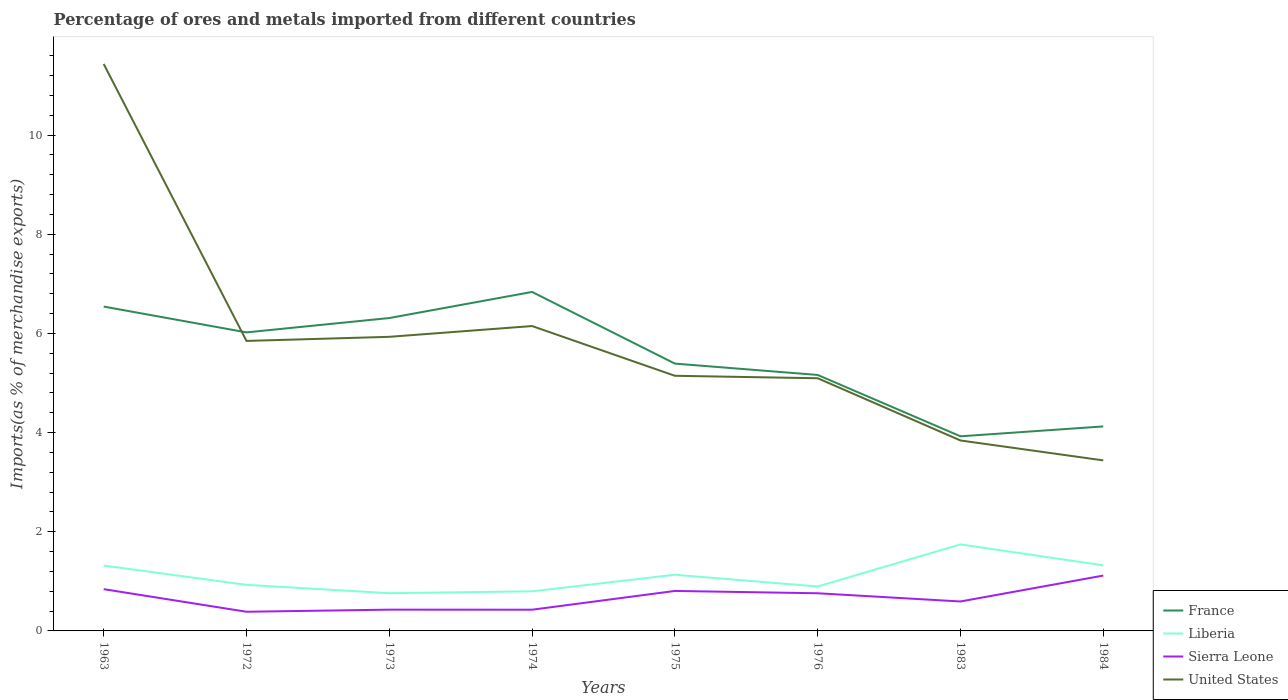Across all years, what is the maximum percentage of imports to different countries in Sierra Leone?
Keep it short and to the point. 0.39. What is the total percentage of imports to different countries in France in the graph?
Keep it short and to the point. 2.1. What is the difference between the highest and the second highest percentage of imports to different countries in France?
Your answer should be very brief. 2.91. What is the difference between two consecutive major ticks on the Y-axis?
Provide a succinct answer. 2. Does the graph contain grids?
Keep it short and to the point. No. How many legend labels are there?
Your response must be concise. 4. How are the legend labels stacked?
Make the answer very short. Vertical. What is the title of the graph?
Offer a very short reply. Percentage of ores and metals imported from different countries. Does "French Polynesia" appear as one of the legend labels in the graph?
Your answer should be very brief. No. What is the label or title of the X-axis?
Keep it short and to the point. Years. What is the label or title of the Y-axis?
Your answer should be compact. Imports(as % of merchandise exports). What is the Imports(as % of merchandise exports) in France in 1963?
Ensure brevity in your answer.  6.54. What is the Imports(as % of merchandise exports) in Liberia in 1963?
Ensure brevity in your answer.  1.32. What is the Imports(as % of merchandise exports) of Sierra Leone in 1963?
Your answer should be compact. 0.84. What is the Imports(as % of merchandise exports) in United States in 1963?
Your answer should be compact. 11.43. What is the Imports(as % of merchandise exports) of France in 1972?
Give a very brief answer. 6.02. What is the Imports(as % of merchandise exports) in Liberia in 1972?
Ensure brevity in your answer.  0.93. What is the Imports(as % of merchandise exports) in Sierra Leone in 1972?
Ensure brevity in your answer.  0.39. What is the Imports(as % of merchandise exports) in United States in 1972?
Keep it short and to the point. 5.85. What is the Imports(as % of merchandise exports) of France in 1973?
Your answer should be compact. 6.31. What is the Imports(as % of merchandise exports) in Liberia in 1973?
Your answer should be compact. 0.76. What is the Imports(as % of merchandise exports) of Sierra Leone in 1973?
Offer a terse response. 0.43. What is the Imports(as % of merchandise exports) in United States in 1973?
Offer a very short reply. 5.93. What is the Imports(as % of merchandise exports) of France in 1974?
Keep it short and to the point. 6.84. What is the Imports(as % of merchandise exports) of Liberia in 1974?
Ensure brevity in your answer.  0.8. What is the Imports(as % of merchandise exports) of Sierra Leone in 1974?
Give a very brief answer. 0.43. What is the Imports(as % of merchandise exports) in United States in 1974?
Offer a terse response. 6.15. What is the Imports(as % of merchandise exports) of France in 1975?
Provide a short and direct response. 5.39. What is the Imports(as % of merchandise exports) of Liberia in 1975?
Provide a succinct answer. 1.13. What is the Imports(as % of merchandise exports) in Sierra Leone in 1975?
Make the answer very short. 0.81. What is the Imports(as % of merchandise exports) of United States in 1975?
Provide a succinct answer. 5.15. What is the Imports(as % of merchandise exports) of France in 1976?
Offer a very short reply. 5.16. What is the Imports(as % of merchandise exports) in Liberia in 1976?
Your response must be concise. 0.9. What is the Imports(as % of merchandise exports) of Sierra Leone in 1976?
Keep it short and to the point. 0.76. What is the Imports(as % of merchandise exports) in United States in 1976?
Offer a terse response. 5.1. What is the Imports(as % of merchandise exports) in France in 1983?
Your response must be concise. 3.93. What is the Imports(as % of merchandise exports) in Liberia in 1983?
Offer a terse response. 1.74. What is the Imports(as % of merchandise exports) in Sierra Leone in 1983?
Offer a terse response. 0.59. What is the Imports(as % of merchandise exports) in United States in 1983?
Offer a terse response. 3.84. What is the Imports(as % of merchandise exports) in France in 1984?
Provide a succinct answer. 4.12. What is the Imports(as % of merchandise exports) in Liberia in 1984?
Ensure brevity in your answer.  1.32. What is the Imports(as % of merchandise exports) of Sierra Leone in 1984?
Your response must be concise. 1.12. What is the Imports(as % of merchandise exports) in United States in 1984?
Provide a succinct answer. 3.44. Across all years, what is the maximum Imports(as % of merchandise exports) of France?
Keep it short and to the point. 6.84. Across all years, what is the maximum Imports(as % of merchandise exports) of Liberia?
Your answer should be compact. 1.74. Across all years, what is the maximum Imports(as % of merchandise exports) of Sierra Leone?
Provide a short and direct response. 1.12. Across all years, what is the maximum Imports(as % of merchandise exports) in United States?
Your response must be concise. 11.43. Across all years, what is the minimum Imports(as % of merchandise exports) of France?
Offer a terse response. 3.93. Across all years, what is the minimum Imports(as % of merchandise exports) of Liberia?
Your response must be concise. 0.76. Across all years, what is the minimum Imports(as % of merchandise exports) of Sierra Leone?
Your answer should be very brief. 0.39. Across all years, what is the minimum Imports(as % of merchandise exports) in United States?
Keep it short and to the point. 3.44. What is the total Imports(as % of merchandise exports) in France in the graph?
Provide a succinct answer. 44.31. What is the total Imports(as % of merchandise exports) of Liberia in the graph?
Your answer should be compact. 8.9. What is the total Imports(as % of merchandise exports) of Sierra Leone in the graph?
Offer a very short reply. 5.36. What is the total Imports(as % of merchandise exports) in United States in the graph?
Give a very brief answer. 46.89. What is the difference between the Imports(as % of merchandise exports) of France in 1963 and that in 1972?
Provide a short and direct response. 0.52. What is the difference between the Imports(as % of merchandise exports) in Liberia in 1963 and that in 1972?
Provide a short and direct response. 0.39. What is the difference between the Imports(as % of merchandise exports) of Sierra Leone in 1963 and that in 1972?
Keep it short and to the point. 0.46. What is the difference between the Imports(as % of merchandise exports) of United States in 1963 and that in 1972?
Your response must be concise. 5.59. What is the difference between the Imports(as % of merchandise exports) of France in 1963 and that in 1973?
Keep it short and to the point. 0.23. What is the difference between the Imports(as % of merchandise exports) of Liberia in 1963 and that in 1973?
Make the answer very short. 0.56. What is the difference between the Imports(as % of merchandise exports) in Sierra Leone in 1963 and that in 1973?
Give a very brief answer. 0.41. What is the difference between the Imports(as % of merchandise exports) in United States in 1963 and that in 1973?
Offer a terse response. 5.5. What is the difference between the Imports(as % of merchandise exports) of France in 1963 and that in 1974?
Give a very brief answer. -0.29. What is the difference between the Imports(as % of merchandise exports) in Liberia in 1963 and that in 1974?
Your answer should be very brief. 0.52. What is the difference between the Imports(as % of merchandise exports) of Sierra Leone in 1963 and that in 1974?
Provide a succinct answer. 0.41. What is the difference between the Imports(as % of merchandise exports) of United States in 1963 and that in 1974?
Your answer should be compact. 5.29. What is the difference between the Imports(as % of merchandise exports) of France in 1963 and that in 1975?
Offer a very short reply. 1.15. What is the difference between the Imports(as % of merchandise exports) in Liberia in 1963 and that in 1975?
Make the answer very short. 0.18. What is the difference between the Imports(as % of merchandise exports) of Sierra Leone in 1963 and that in 1975?
Offer a terse response. 0.04. What is the difference between the Imports(as % of merchandise exports) of United States in 1963 and that in 1975?
Your answer should be compact. 6.29. What is the difference between the Imports(as % of merchandise exports) in France in 1963 and that in 1976?
Ensure brevity in your answer.  1.38. What is the difference between the Imports(as % of merchandise exports) in Liberia in 1963 and that in 1976?
Provide a short and direct response. 0.42. What is the difference between the Imports(as % of merchandise exports) in Sierra Leone in 1963 and that in 1976?
Provide a succinct answer. 0.08. What is the difference between the Imports(as % of merchandise exports) in United States in 1963 and that in 1976?
Make the answer very short. 6.34. What is the difference between the Imports(as % of merchandise exports) in France in 1963 and that in 1983?
Your answer should be compact. 2.62. What is the difference between the Imports(as % of merchandise exports) of Liberia in 1963 and that in 1983?
Ensure brevity in your answer.  -0.43. What is the difference between the Imports(as % of merchandise exports) of Sierra Leone in 1963 and that in 1983?
Your response must be concise. 0.25. What is the difference between the Imports(as % of merchandise exports) in United States in 1963 and that in 1983?
Give a very brief answer. 7.59. What is the difference between the Imports(as % of merchandise exports) of France in 1963 and that in 1984?
Provide a succinct answer. 2.42. What is the difference between the Imports(as % of merchandise exports) of Liberia in 1963 and that in 1984?
Make the answer very short. -0. What is the difference between the Imports(as % of merchandise exports) in Sierra Leone in 1963 and that in 1984?
Make the answer very short. -0.27. What is the difference between the Imports(as % of merchandise exports) of United States in 1963 and that in 1984?
Provide a succinct answer. 8. What is the difference between the Imports(as % of merchandise exports) of France in 1972 and that in 1973?
Your answer should be very brief. -0.29. What is the difference between the Imports(as % of merchandise exports) of Liberia in 1972 and that in 1973?
Your answer should be very brief. 0.17. What is the difference between the Imports(as % of merchandise exports) in Sierra Leone in 1972 and that in 1973?
Offer a very short reply. -0.04. What is the difference between the Imports(as % of merchandise exports) in United States in 1972 and that in 1973?
Provide a short and direct response. -0.08. What is the difference between the Imports(as % of merchandise exports) in France in 1972 and that in 1974?
Your response must be concise. -0.82. What is the difference between the Imports(as % of merchandise exports) of Liberia in 1972 and that in 1974?
Your response must be concise. 0.13. What is the difference between the Imports(as % of merchandise exports) of Sierra Leone in 1972 and that in 1974?
Offer a very short reply. -0.04. What is the difference between the Imports(as % of merchandise exports) of United States in 1972 and that in 1974?
Offer a terse response. -0.3. What is the difference between the Imports(as % of merchandise exports) of France in 1972 and that in 1975?
Offer a terse response. 0.63. What is the difference between the Imports(as % of merchandise exports) of Liberia in 1972 and that in 1975?
Make the answer very short. -0.2. What is the difference between the Imports(as % of merchandise exports) in Sierra Leone in 1972 and that in 1975?
Give a very brief answer. -0.42. What is the difference between the Imports(as % of merchandise exports) in United States in 1972 and that in 1975?
Make the answer very short. 0.7. What is the difference between the Imports(as % of merchandise exports) of France in 1972 and that in 1976?
Ensure brevity in your answer.  0.86. What is the difference between the Imports(as % of merchandise exports) of Liberia in 1972 and that in 1976?
Your answer should be compact. 0.03. What is the difference between the Imports(as % of merchandise exports) in Sierra Leone in 1972 and that in 1976?
Offer a terse response. -0.37. What is the difference between the Imports(as % of merchandise exports) of United States in 1972 and that in 1976?
Provide a succinct answer. 0.75. What is the difference between the Imports(as % of merchandise exports) in France in 1972 and that in 1983?
Your answer should be compact. 2.1. What is the difference between the Imports(as % of merchandise exports) in Liberia in 1972 and that in 1983?
Offer a very short reply. -0.82. What is the difference between the Imports(as % of merchandise exports) of Sierra Leone in 1972 and that in 1983?
Your answer should be very brief. -0.21. What is the difference between the Imports(as % of merchandise exports) of United States in 1972 and that in 1983?
Offer a very short reply. 2.01. What is the difference between the Imports(as % of merchandise exports) in France in 1972 and that in 1984?
Keep it short and to the point. 1.9. What is the difference between the Imports(as % of merchandise exports) in Liberia in 1972 and that in 1984?
Provide a succinct answer. -0.39. What is the difference between the Imports(as % of merchandise exports) in Sierra Leone in 1972 and that in 1984?
Provide a short and direct response. -0.73. What is the difference between the Imports(as % of merchandise exports) in United States in 1972 and that in 1984?
Ensure brevity in your answer.  2.41. What is the difference between the Imports(as % of merchandise exports) in France in 1973 and that in 1974?
Offer a very short reply. -0.53. What is the difference between the Imports(as % of merchandise exports) of Liberia in 1973 and that in 1974?
Offer a terse response. -0.04. What is the difference between the Imports(as % of merchandise exports) in Sierra Leone in 1973 and that in 1974?
Provide a succinct answer. 0. What is the difference between the Imports(as % of merchandise exports) of United States in 1973 and that in 1974?
Offer a very short reply. -0.22. What is the difference between the Imports(as % of merchandise exports) in France in 1973 and that in 1975?
Make the answer very short. 0.92. What is the difference between the Imports(as % of merchandise exports) of Liberia in 1973 and that in 1975?
Offer a terse response. -0.37. What is the difference between the Imports(as % of merchandise exports) of Sierra Leone in 1973 and that in 1975?
Your answer should be very brief. -0.38. What is the difference between the Imports(as % of merchandise exports) in United States in 1973 and that in 1975?
Ensure brevity in your answer.  0.79. What is the difference between the Imports(as % of merchandise exports) of France in 1973 and that in 1976?
Ensure brevity in your answer.  1.15. What is the difference between the Imports(as % of merchandise exports) of Liberia in 1973 and that in 1976?
Your answer should be very brief. -0.14. What is the difference between the Imports(as % of merchandise exports) in Sierra Leone in 1973 and that in 1976?
Make the answer very short. -0.33. What is the difference between the Imports(as % of merchandise exports) in United States in 1973 and that in 1976?
Offer a very short reply. 0.84. What is the difference between the Imports(as % of merchandise exports) of France in 1973 and that in 1983?
Keep it short and to the point. 2.39. What is the difference between the Imports(as % of merchandise exports) in Liberia in 1973 and that in 1983?
Keep it short and to the point. -0.98. What is the difference between the Imports(as % of merchandise exports) in Sierra Leone in 1973 and that in 1983?
Provide a succinct answer. -0.16. What is the difference between the Imports(as % of merchandise exports) in United States in 1973 and that in 1983?
Give a very brief answer. 2.09. What is the difference between the Imports(as % of merchandise exports) of France in 1973 and that in 1984?
Your answer should be compact. 2.19. What is the difference between the Imports(as % of merchandise exports) in Liberia in 1973 and that in 1984?
Keep it short and to the point. -0.56. What is the difference between the Imports(as % of merchandise exports) of Sierra Leone in 1973 and that in 1984?
Your answer should be compact. -0.69. What is the difference between the Imports(as % of merchandise exports) of United States in 1973 and that in 1984?
Make the answer very short. 2.49. What is the difference between the Imports(as % of merchandise exports) of France in 1974 and that in 1975?
Your response must be concise. 1.45. What is the difference between the Imports(as % of merchandise exports) of Liberia in 1974 and that in 1975?
Offer a very short reply. -0.33. What is the difference between the Imports(as % of merchandise exports) in Sierra Leone in 1974 and that in 1975?
Provide a succinct answer. -0.38. What is the difference between the Imports(as % of merchandise exports) of United States in 1974 and that in 1975?
Keep it short and to the point. 1. What is the difference between the Imports(as % of merchandise exports) in France in 1974 and that in 1976?
Your response must be concise. 1.67. What is the difference between the Imports(as % of merchandise exports) of Liberia in 1974 and that in 1976?
Your response must be concise. -0.1. What is the difference between the Imports(as % of merchandise exports) of Sierra Leone in 1974 and that in 1976?
Give a very brief answer. -0.33. What is the difference between the Imports(as % of merchandise exports) of United States in 1974 and that in 1976?
Provide a short and direct response. 1.05. What is the difference between the Imports(as % of merchandise exports) in France in 1974 and that in 1983?
Ensure brevity in your answer.  2.91. What is the difference between the Imports(as % of merchandise exports) of Liberia in 1974 and that in 1983?
Offer a terse response. -0.95. What is the difference between the Imports(as % of merchandise exports) of Sierra Leone in 1974 and that in 1983?
Offer a very short reply. -0.17. What is the difference between the Imports(as % of merchandise exports) of United States in 1974 and that in 1983?
Your response must be concise. 2.31. What is the difference between the Imports(as % of merchandise exports) of France in 1974 and that in 1984?
Make the answer very short. 2.71. What is the difference between the Imports(as % of merchandise exports) in Liberia in 1974 and that in 1984?
Offer a terse response. -0.52. What is the difference between the Imports(as % of merchandise exports) in Sierra Leone in 1974 and that in 1984?
Your response must be concise. -0.69. What is the difference between the Imports(as % of merchandise exports) in United States in 1974 and that in 1984?
Your answer should be very brief. 2.71. What is the difference between the Imports(as % of merchandise exports) of France in 1975 and that in 1976?
Ensure brevity in your answer.  0.23. What is the difference between the Imports(as % of merchandise exports) in Liberia in 1975 and that in 1976?
Your response must be concise. 0.24. What is the difference between the Imports(as % of merchandise exports) of Sierra Leone in 1975 and that in 1976?
Offer a very short reply. 0.05. What is the difference between the Imports(as % of merchandise exports) in United States in 1975 and that in 1976?
Your answer should be compact. 0.05. What is the difference between the Imports(as % of merchandise exports) of France in 1975 and that in 1983?
Make the answer very short. 1.47. What is the difference between the Imports(as % of merchandise exports) of Liberia in 1975 and that in 1983?
Ensure brevity in your answer.  -0.61. What is the difference between the Imports(as % of merchandise exports) in Sierra Leone in 1975 and that in 1983?
Make the answer very short. 0.21. What is the difference between the Imports(as % of merchandise exports) in United States in 1975 and that in 1983?
Your answer should be very brief. 1.3. What is the difference between the Imports(as % of merchandise exports) of France in 1975 and that in 1984?
Keep it short and to the point. 1.27. What is the difference between the Imports(as % of merchandise exports) in Liberia in 1975 and that in 1984?
Give a very brief answer. -0.19. What is the difference between the Imports(as % of merchandise exports) of Sierra Leone in 1975 and that in 1984?
Your response must be concise. -0.31. What is the difference between the Imports(as % of merchandise exports) in United States in 1975 and that in 1984?
Your answer should be very brief. 1.71. What is the difference between the Imports(as % of merchandise exports) of France in 1976 and that in 1983?
Your answer should be very brief. 1.24. What is the difference between the Imports(as % of merchandise exports) of Liberia in 1976 and that in 1983?
Provide a short and direct response. -0.85. What is the difference between the Imports(as % of merchandise exports) in Sierra Leone in 1976 and that in 1983?
Provide a succinct answer. 0.17. What is the difference between the Imports(as % of merchandise exports) in United States in 1976 and that in 1983?
Offer a terse response. 1.26. What is the difference between the Imports(as % of merchandise exports) in France in 1976 and that in 1984?
Give a very brief answer. 1.04. What is the difference between the Imports(as % of merchandise exports) of Liberia in 1976 and that in 1984?
Offer a very short reply. -0.43. What is the difference between the Imports(as % of merchandise exports) of Sierra Leone in 1976 and that in 1984?
Provide a succinct answer. -0.36. What is the difference between the Imports(as % of merchandise exports) in United States in 1976 and that in 1984?
Ensure brevity in your answer.  1.66. What is the difference between the Imports(as % of merchandise exports) in France in 1983 and that in 1984?
Offer a terse response. -0.2. What is the difference between the Imports(as % of merchandise exports) of Liberia in 1983 and that in 1984?
Your response must be concise. 0.42. What is the difference between the Imports(as % of merchandise exports) of Sierra Leone in 1983 and that in 1984?
Your answer should be very brief. -0.52. What is the difference between the Imports(as % of merchandise exports) in United States in 1983 and that in 1984?
Offer a very short reply. 0.4. What is the difference between the Imports(as % of merchandise exports) in France in 1963 and the Imports(as % of merchandise exports) in Liberia in 1972?
Your response must be concise. 5.61. What is the difference between the Imports(as % of merchandise exports) in France in 1963 and the Imports(as % of merchandise exports) in Sierra Leone in 1972?
Ensure brevity in your answer.  6.16. What is the difference between the Imports(as % of merchandise exports) in France in 1963 and the Imports(as % of merchandise exports) in United States in 1972?
Keep it short and to the point. 0.69. What is the difference between the Imports(as % of merchandise exports) in Liberia in 1963 and the Imports(as % of merchandise exports) in Sierra Leone in 1972?
Your response must be concise. 0.93. What is the difference between the Imports(as % of merchandise exports) of Liberia in 1963 and the Imports(as % of merchandise exports) of United States in 1972?
Ensure brevity in your answer.  -4.53. What is the difference between the Imports(as % of merchandise exports) in Sierra Leone in 1963 and the Imports(as % of merchandise exports) in United States in 1972?
Offer a very short reply. -5.01. What is the difference between the Imports(as % of merchandise exports) in France in 1963 and the Imports(as % of merchandise exports) in Liberia in 1973?
Ensure brevity in your answer.  5.78. What is the difference between the Imports(as % of merchandise exports) in France in 1963 and the Imports(as % of merchandise exports) in Sierra Leone in 1973?
Keep it short and to the point. 6.11. What is the difference between the Imports(as % of merchandise exports) of France in 1963 and the Imports(as % of merchandise exports) of United States in 1973?
Your response must be concise. 0.61. What is the difference between the Imports(as % of merchandise exports) in Liberia in 1963 and the Imports(as % of merchandise exports) in Sierra Leone in 1973?
Keep it short and to the point. 0.89. What is the difference between the Imports(as % of merchandise exports) of Liberia in 1963 and the Imports(as % of merchandise exports) of United States in 1973?
Make the answer very short. -4.61. What is the difference between the Imports(as % of merchandise exports) in Sierra Leone in 1963 and the Imports(as % of merchandise exports) in United States in 1973?
Keep it short and to the point. -5.09. What is the difference between the Imports(as % of merchandise exports) in France in 1963 and the Imports(as % of merchandise exports) in Liberia in 1974?
Give a very brief answer. 5.74. What is the difference between the Imports(as % of merchandise exports) in France in 1963 and the Imports(as % of merchandise exports) in Sierra Leone in 1974?
Your answer should be very brief. 6.11. What is the difference between the Imports(as % of merchandise exports) in France in 1963 and the Imports(as % of merchandise exports) in United States in 1974?
Your answer should be very brief. 0.39. What is the difference between the Imports(as % of merchandise exports) in Liberia in 1963 and the Imports(as % of merchandise exports) in Sierra Leone in 1974?
Ensure brevity in your answer.  0.89. What is the difference between the Imports(as % of merchandise exports) in Liberia in 1963 and the Imports(as % of merchandise exports) in United States in 1974?
Your answer should be very brief. -4.83. What is the difference between the Imports(as % of merchandise exports) in Sierra Leone in 1963 and the Imports(as % of merchandise exports) in United States in 1974?
Your answer should be compact. -5.31. What is the difference between the Imports(as % of merchandise exports) of France in 1963 and the Imports(as % of merchandise exports) of Liberia in 1975?
Give a very brief answer. 5.41. What is the difference between the Imports(as % of merchandise exports) of France in 1963 and the Imports(as % of merchandise exports) of Sierra Leone in 1975?
Provide a short and direct response. 5.74. What is the difference between the Imports(as % of merchandise exports) in France in 1963 and the Imports(as % of merchandise exports) in United States in 1975?
Offer a very short reply. 1.4. What is the difference between the Imports(as % of merchandise exports) of Liberia in 1963 and the Imports(as % of merchandise exports) of Sierra Leone in 1975?
Your response must be concise. 0.51. What is the difference between the Imports(as % of merchandise exports) in Liberia in 1963 and the Imports(as % of merchandise exports) in United States in 1975?
Provide a succinct answer. -3.83. What is the difference between the Imports(as % of merchandise exports) in Sierra Leone in 1963 and the Imports(as % of merchandise exports) in United States in 1975?
Offer a terse response. -4.3. What is the difference between the Imports(as % of merchandise exports) of France in 1963 and the Imports(as % of merchandise exports) of Liberia in 1976?
Your answer should be very brief. 5.65. What is the difference between the Imports(as % of merchandise exports) in France in 1963 and the Imports(as % of merchandise exports) in Sierra Leone in 1976?
Offer a terse response. 5.78. What is the difference between the Imports(as % of merchandise exports) in France in 1963 and the Imports(as % of merchandise exports) in United States in 1976?
Your answer should be very brief. 1.45. What is the difference between the Imports(as % of merchandise exports) of Liberia in 1963 and the Imports(as % of merchandise exports) of Sierra Leone in 1976?
Make the answer very short. 0.56. What is the difference between the Imports(as % of merchandise exports) in Liberia in 1963 and the Imports(as % of merchandise exports) in United States in 1976?
Your answer should be compact. -3.78. What is the difference between the Imports(as % of merchandise exports) of Sierra Leone in 1963 and the Imports(as % of merchandise exports) of United States in 1976?
Ensure brevity in your answer.  -4.25. What is the difference between the Imports(as % of merchandise exports) in France in 1963 and the Imports(as % of merchandise exports) in Liberia in 1983?
Your answer should be compact. 4.8. What is the difference between the Imports(as % of merchandise exports) in France in 1963 and the Imports(as % of merchandise exports) in Sierra Leone in 1983?
Your response must be concise. 5.95. What is the difference between the Imports(as % of merchandise exports) of France in 1963 and the Imports(as % of merchandise exports) of United States in 1983?
Your answer should be compact. 2.7. What is the difference between the Imports(as % of merchandise exports) of Liberia in 1963 and the Imports(as % of merchandise exports) of Sierra Leone in 1983?
Your answer should be very brief. 0.72. What is the difference between the Imports(as % of merchandise exports) of Liberia in 1963 and the Imports(as % of merchandise exports) of United States in 1983?
Provide a succinct answer. -2.52. What is the difference between the Imports(as % of merchandise exports) of Sierra Leone in 1963 and the Imports(as % of merchandise exports) of United States in 1983?
Make the answer very short. -3. What is the difference between the Imports(as % of merchandise exports) of France in 1963 and the Imports(as % of merchandise exports) of Liberia in 1984?
Your answer should be very brief. 5.22. What is the difference between the Imports(as % of merchandise exports) of France in 1963 and the Imports(as % of merchandise exports) of Sierra Leone in 1984?
Keep it short and to the point. 5.43. What is the difference between the Imports(as % of merchandise exports) of France in 1963 and the Imports(as % of merchandise exports) of United States in 1984?
Your answer should be compact. 3.1. What is the difference between the Imports(as % of merchandise exports) in Liberia in 1963 and the Imports(as % of merchandise exports) in Sierra Leone in 1984?
Offer a very short reply. 0.2. What is the difference between the Imports(as % of merchandise exports) of Liberia in 1963 and the Imports(as % of merchandise exports) of United States in 1984?
Provide a short and direct response. -2.12. What is the difference between the Imports(as % of merchandise exports) of Sierra Leone in 1963 and the Imports(as % of merchandise exports) of United States in 1984?
Make the answer very short. -2.6. What is the difference between the Imports(as % of merchandise exports) of France in 1972 and the Imports(as % of merchandise exports) of Liberia in 1973?
Give a very brief answer. 5.26. What is the difference between the Imports(as % of merchandise exports) in France in 1972 and the Imports(as % of merchandise exports) in Sierra Leone in 1973?
Offer a terse response. 5.59. What is the difference between the Imports(as % of merchandise exports) of France in 1972 and the Imports(as % of merchandise exports) of United States in 1973?
Provide a succinct answer. 0.09. What is the difference between the Imports(as % of merchandise exports) in Liberia in 1972 and the Imports(as % of merchandise exports) in Sierra Leone in 1973?
Provide a short and direct response. 0.5. What is the difference between the Imports(as % of merchandise exports) of Liberia in 1972 and the Imports(as % of merchandise exports) of United States in 1973?
Ensure brevity in your answer.  -5. What is the difference between the Imports(as % of merchandise exports) of Sierra Leone in 1972 and the Imports(as % of merchandise exports) of United States in 1973?
Make the answer very short. -5.54. What is the difference between the Imports(as % of merchandise exports) in France in 1972 and the Imports(as % of merchandise exports) in Liberia in 1974?
Ensure brevity in your answer.  5.22. What is the difference between the Imports(as % of merchandise exports) of France in 1972 and the Imports(as % of merchandise exports) of Sierra Leone in 1974?
Provide a short and direct response. 5.59. What is the difference between the Imports(as % of merchandise exports) in France in 1972 and the Imports(as % of merchandise exports) in United States in 1974?
Your answer should be very brief. -0.13. What is the difference between the Imports(as % of merchandise exports) in Liberia in 1972 and the Imports(as % of merchandise exports) in Sierra Leone in 1974?
Keep it short and to the point. 0.5. What is the difference between the Imports(as % of merchandise exports) in Liberia in 1972 and the Imports(as % of merchandise exports) in United States in 1974?
Offer a very short reply. -5.22. What is the difference between the Imports(as % of merchandise exports) of Sierra Leone in 1972 and the Imports(as % of merchandise exports) of United States in 1974?
Offer a terse response. -5.76. What is the difference between the Imports(as % of merchandise exports) in France in 1972 and the Imports(as % of merchandise exports) in Liberia in 1975?
Give a very brief answer. 4.89. What is the difference between the Imports(as % of merchandise exports) of France in 1972 and the Imports(as % of merchandise exports) of Sierra Leone in 1975?
Give a very brief answer. 5.21. What is the difference between the Imports(as % of merchandise exports) of France in 1972 and the Imports(as % of merchandise exports) of United States in 1975?
Your response must be concise. 0.88. What is the difference between the Imports(as % of merchandise exports) of Liberia in 1972 and the Imports(as % of merchandise exports) of Sierra Leone in 1975?
Your answer should be very brief. 0.12. What is the difference between the Imports(as % of merchandise exports) of Liberia in 1972 and the Imports(as % of merchandise exports) of United States in 1975?
Offer a very short reply. -4.22. What is the difference between the Imports(as % of merchandise exports) of Sierra Leone in 1972 and the Imports(as % of merchandise exports) of United States in 1975?
Offer a very short reply. -4.76. What is the difference between the Imports(as % of merchandise exports) in France in 1972 and the Imports(as % of merchandise exports) in Liberia in 1976?
Your answer should be very brief. 5.12. What is the difference between the Imports(as % of merchandise exports) of France in 1972 and the Imports(as % of merchandise exports) of Sierra Leone in 1976?
Offer a very short reply. 5.26. What is the difference between the Imports(as % of merchandise exports) of France in 1972 and the Imports(as % of merchandise exports) of United States in 1976?
Offer a very short reply. 0.92. What is the difference between the Imports(as % of merchandise exports) in Liberia in 1972 and the Imports(as % of merchandise exports) in Sierra Leone in 1976?
Your answer should be very brief. 0.17. What is the difference between the Imports(as % of merchandise exports) in Liberia in 1972 and the Imports(as % of merchandise exports) in United States in 1976?
Make the answer very short. -4.17. What is the difference between the Imports(as % of merchandise exports) in Sierra Leone in 1972 and the Imports(as % of merchandise exports) in United States in 1976?
Your answer should be compact. -4.71. What is the difference between the Imports(as % of merchandise exports) in France in 1972 and the Imports(as % of merchandise exports) in Liberia in 1983?
Make the answer very short. 4.28. What is the difference between the Imports(as % of merchandise exports) of France in 1972 and the Imports(as % of merchandise exports) of Sierra Leone in 1983?
Ensure brevity in your answer.  5.43. What is the difference between the Imports(as % of merchandise exports) in France in 1972 and the Imports(as % of merchandise exports) in United States in 1983?
Keep it short and to the point. 2.18. What is the difference between the Imports(as % of merchandise exports) in Liberia in 1972 and the Imports(as % of merchandise exports) in Sierra Leone in 1983?
Make the answer very short. 0.34. What is the difference between the Imports(as % of merchandise exports) in Liberia in 1972 and the Imports(as % of merchandise exports) in United States in 1983?
Offer a very short reply. -2.91. What is the difference between the Imports(as % of merchandise exports) in Sierra Leone in 1972 and the Imports(as % of merchandise exports) in United States in 1983?
Provide a short and direct response. -3.45. What is the difference between the Imports(as % of merchandise exports) in France in 1972 and the Imports(as % of merchandise exports) in Liberia in 1984?
Keep it short and to the point. 4.7. What is the difference between the Imports(as % of merchandise exports) in France in 1972 and the Imports(as % of merchandise exports) in Sierra Leone in 1984?
Make the answer very short. 4.9. What is the difference between the Imports(as % of merchandise exports) of France in 1972 and the Imports(as % of merchandise exports) of United States in 1984?
Your response must be concise. 2.58. What is the difference between the Imports(as % of merchandise exports) of Liberia in 1972 and the Imports(as % of merchandise exports) of Sierra Leone in 1984?
Your answer should be very brief. -0.19. What is the difference between the Imports(as % of merchandise exports) of Liberia in 1972 and the Imports(as % of merchandise exports) of United States in 1984?
Provide a succinct answer. -2.51. What is the difference between the Imports(as % of merchandise exports) in Sierra Leone in 1972 and the Imports(as % of merchandise exports) in United States in 1984?
Provide a short and direct response. -3.05. What is the difference between the Imports(as % of merchandise exports) of France in 1973 and the Imports(as % of merchandise exports) of Liberia in 1974?
Offer a very short reply. 5.51. What is the difference between the Imports(as % of merchandise exports) in France in 1973 and the Imports(as % of merchandise exports) in Sierra Leone in 1974?
Provide a succinct answer. 5.88. What is the difference between the Imports(as % of merchandise exports) of France in 1973 and the Imports(as % of merchandise exports) of United States in 1974?
Provide a succinct answer. 0.16. What is the difference between the Imports(as % of merchandise exports) of Liberia in 1973 and the Imports(as % of merchandise exports) of Sierra Leone in 1974?
Provide a succinct answer. 0.33. What is the difference between the Imports(as % of merchandise exports) of Liberia in 1973 and the Imports(as % of merchandise exports) of United States in 1974?
Provide a short and direct response. -5.39. What is the difference between the Imports(as % of merchandise exports) in Sierra Leone in 1973 and the Imports(as % of merchandise exports) in United States in 1974?
Provide a short and direct response. -5.72. What is the difference between the Imports(as % of merchandise exports) of France in 1973 and the Imports(as % of merchandise exports) of Liberia in 1975?
Give a very brief answer. 5.18. What is the difference between the Imports(as % of merchandise exports) of France in 1973 and the Imports(as % of merchandise exports) of Sierra Leone in 1975?
Offer a very short reply. 5.5. What is the difference between the Imports(as % of merchandise exports) in France in 1973 and the Imports(as % of merchandise exports) in United States in 1975?
Offer a very short reply. 1.16. What is the difference between the Imports(as % of merchandise exports) of Liberia in 1973 and the Imports(as % of merchandise exports) of Sierra Leone in 1975?
Provide a succinct answer. -0.05. What is the difference between the Imports(as % of merchandise exports) of Liberia in 1973 and the Imports(as % of merchandise exports) of United States in 1975?
Your answer should be compact. -4.38. What is the difference between the Imports(as % of merchandise exports) in Sierra Leone in 1973 and the Imports(as % of merchandise exports) in United States in 1975?
Keep it short and to the point. -4.72. What is the difference between the Imports(as % of merchandise exports) of France in 1973 and the Imports(as % of merchandise exports) of Liberia in 1976?
Your answer should be compact. 5.41. What is the difference between the Imports(as % of merchandise exports) of France in 1973 and the Imports(as % of merchandise exports) of Sierra Leone in 1976?
Offer a very short reply. 5.55. What is the difference between the Imports(as % of merchandise exports) of France in 1973 and the Imports(as % of merchandise exports) of United States in 1976?
Your response must be concise. 1.21. What is the difference between the Imports(as % of merchandise exports) in Liberia in 1973 and the Imports(as % of merchandise exports) in Sierra Leone in 1976?
Your answer should be compact. 0. What is the difference between the Imports(as % of merchandise exports) of Liberia in 1973 and the Imports(as % of merchandise exports) of United States in 1976?
Offer a terse response. -4.34. What is the difference between the Imports(as % of merchandise exports) of Sierra Leone in 1973 and the Imports(as % of merchandise exports) of United States in 1976?
Provide a succinct answer. -4.67. What is the difference between the Imports(as % of merchandise exports) of France in 1973 and the Imports(as % of merchandise exports) of Liberia in 1983?
Your answer should be compact. 4.57. What is the difference between the Imports(as % of merchandise exports) in France in 1973 and the Imports(as % of merchandise exports) in Sierra Leone in 1983?
Make the answer very short. 5.72. What is the difference between the Imports(as % of merchandise exports) in France in 1973 and the Imports(as % of merchandise exports) in United States in 1983?
Offer a terse response. 2.47. What is the difference between the Imports(as % of merchandise exports) in Liberia in 1973 and the Imports(as % of merchandise exports) in Sierra Leone in 1983?
Offer a terse response. 0.17. What is the difference between the Imports(as % of merchandise exports) of Liberia in 1973 and the Imports(as % of merchandise exports) of United States in 1983?
Keep it short and to the point. -3.08. What is the difference between the Imports(as % of merchandise exports) in Sierra Leone in 1973 and the Imports(as % of merchandise exports) in United States in 1983?
Offer a very short reply. -3.41. What is the difference between the Imports(as % of merchandise exports) of France in 1973 and the Imports(as % of merchandise exports) of Liberia in 1984?
Provide a short and direct response. 4.99. What is the difference between the Imports(as % of merchandise exports) in France in 1973 and the Imports(as % of merchandise exports) in Sierra Leone in 1984?
Ensure brevity in your answer.  5.19. What is the difference between the Imports(as % of merchandise exports) in France in 1973 and the Imports(as % of merchandise exports) in United States in 1984?
Your response must be concise. 2.87. What is the difference between the Imports(as % of merchandise exports) of Liberia in 1973 and the Imports(as % of merchandise exports) of Sierra Leone in 1984?
Make the answer very short. -0.36. What is the difference between the Imports(as % of merchandise exports) in Liberia in 1973 and the Imports(as % of merchandise exports) in United States in 1984?
Ensure brevity in your answer.  -2.68. What is the difference between the Imports(as % of merchandise exports) of Sierra Leone in 1973 and the Imports(as % of merchandise exports) of United States in 1984?
Offer a terse response. -3.01. What is the difference between the Imports(as % of merchandise exports) of France in 1974 and the Imports(as % of merchandise exports) of Liberia in 1975?
Keep it short and to the point. 5.7. What is the difference between the Imports(as % of merchandise exports) in France in 1974 and the Imports(as % of merchandise exports) in Sierra Leone in 1975?
Provide a short and direct response. 6.03. What is the difference between the Imports(as % of merchandise exports) of France in 1974 and the Imports(as % of merchandise exports) of United States in 1975?
Offer a terse response. 1.69. What is the difference between the Imports(as % of merchandise exports) of Liberia in 1974 and the Imports(as % of merchandise exports) of Sierra Leone in 1975?
Provide a succinct answer. -0.01. What is the difference between the Imports(as % of merchandise exports) of Liberia in 1974 and the Imports(as % of merchandise exports) of United States in 1975?
Your answer should be very brief. -4.35. What is the difference between the Imports(as % of merchandise exports) of Sierra Leone in 1974 and the Imports(as % of merchandise exports) of United States in 1975?
Give a very brief answer. -4.72. What is the difference between the Imports(as % of merchandise exports) of France in 1974 and the Imports(as % of merchandise exports) of Liberia in 1976?
Provide a succinct answer. 5.94. What is the difference between the Imports(as % of merchandise exports) in France in 1974 and the Imports(as % of merchandise exports) in Sierra Leone in 1976?
Your response must be concise. 6.08. What is the difference between the Imports(as % of merchandise exports) in France in 1974 and the Imports(as % of merchandise exports) in United States in 1976?
Give a very brief answer. 1.74. What is the difference between the Imports(as % of merchandise exports) in Liberia in 1974 and the Imports(as % of merchandise exports) in Sierra Leone in 1976?
Provide a short and direct response. 0.04. What is the difference between the Imports(as % of merchandise exports) of Liberia in 1974 and the Imports(as % of merchandise exports) of United States in 1976?
Provide a succinct answer. -4.3. What is the difference between the Imports(as % of merchandise exports) of Sierra Leone in 1974 and the Imports(as % of merchandise exports) of United States in 1976?
Ensure brevity in your answer.  -4.67. What is the difference between the Imports(as % of merchandise exports) in France in 1974 and the Imports(as % of merchandise exports) in Liberia in 1983?
Your answer should be very brief. 5.09. What is the difference between the Imports(as % of merchandise exports) of France in 1974 and the Imports(as % of merchandise exports) of Sierra Leone in 1983?
Give a very brief answer. 6.24. What is the difference between the Imports(as % of merchandise exports) of France in 1974 and the Imports(as % of merchandise exports) of United States in 1983?
Offer a very short reply. 3. What is the difference between the Imports(as % of merchandise exports) in Liberia in 1974 and the Imports(as % of merchandise exports) in Sierra Leone in 1983?
Give a very brief answer. 0.2. What is the difference between the Imports(as % of merchandise exports) in Liberia in 1974 and the Imports(as % of merchandise exports) in United States in 1983?
Give a very brief answer. -3.04. What is the difference between the Imports(as % of merchandise exports) of Sierra Leone in 1974 and the Imports(as % of merchandise exports) of United States in 1983?
Give a very brief answer. -3.41. What is the difference between the Imports(as % of merchandise exports) in France in 1974 and the Imports(as % of merchandise exports) in Liberia in 1984?
Make the answer very short. 5.51. What is the difference between the Imports(as % of merchandise exports) in France in 1974 and the Imports(as % of merchandise exports) in Sierra Leone in 1984?
Offer a terse response. 5.72. What is the difference between the Imports(as % of merchandise exports) of France in 1974 and the Imports(as % of merchandise exports) of United States in 1984?
Offer a very short reply. 3.4. What is the difference between the Imports(as % of merchandise exports) in Liberia in 1974 and the Imports(as % of merchandise exports) in Sierra Leone in 1984?
Ensure brevity in your answer.  -0.32. What is the difference between the Imports(as % of merchandise exports) in Liberia in 1974 and the Imports(as % of merchandise exports) in United States in 1984?
Your response must be concise. -2.64. What is the difference between the Imports(as % of merchandise exports) of Sierra Leone in 1974 and the Imports(as % of merchandise exports) of United States in 1984?
Your answer should be very brief. -3.01. What is the difference between the Imports(as % of merchandise exports) in France in 1975 and the Imports(as % of merchandise exports) in Liberia in 1976?
Give a very brief answer. 4.5. What is the difference between the Imports(as % of merchandise exports) of France in 1975 and the Imports(as % of merchandise exports) of Sierra Leone in 1976?
Ensure brevity in your answer.  4.63. What is the difference between the Imports(as % of merchandise exports) in France in 1975 and the Imports(as % of merchandise exports) in United States in 1976?
Make the answer very short. 0.3. What is the difference between the Imports(as % of merchandise exports) in Liberia in 1975 and the Imports(as % of merchandise exports) in Sierra Leone in 1976?
Your answer should be compact. 0.37. What is the difference between the Imports(as % of merchandise exports) of Liberia in 1975 and the Imports(as % of merchandise exports) of United States in 1976?
Make the answer very short. -3.96. What is the difference between the Imports(as % of merchandise exports) of Sierra Leone in 1975 and the Imports(as % of merchandise exports) of United States in 1976?
Keep it short and to the point. -4.29. What is the difference between the Imports(as % of merchandise exports) of France in 1975 and the Imports(as % of merchandise exports) of Liberia in 1983?
Offer a terse response. 3.65. What is the difference between the Imports(as % of merchandise exports) of France in 1975 and the Imports(as % of merchandise exports) of Sierra Leone in 1983?
Your answer should be compact. 4.8. What is the difference between the Imports(as % of merchandise exports) in France in 1975 and the Imports(as % of merchandise exports) in United States in 1983?
Your response must be concise. 1.55. What is the difference between the Imports(as % of merchandise exports) of Liberia in 1975 and the Imports(as % of merchandise exports) of Sierra Leone in 1983?
Your answer should be compact. 0.54. What is the difference between the Imports(as % of merchandise exports) in Liberia in 1975 and the Imports(as % of merchandise exports) in United States in 1983?
Your answer should be compact. -2.71. What is the difference between the Imports(as % of merchandise exports) in Sierra Leone in 1975 and the Imports(as % of merchandise exports) in United States in 1983?
Keep it short and to the point. -3.03. What is the difference between the Imports(as % of merchandise exports) of France in 1975 and the Imports(as % of merchandise exports) of Liberia in 1984?
Make the answer very short. 4.07. What is the difference between the Imports(as % of merchandise exports) of France in 1975 and the Imports(as % of merchandise exports) of Sierra Leone in 1984?
Keep it short and to the point. 4.27. What is the difference between the Imports(as % of merchandise exports) of France in 1975 and the Imports(as % of merchandise exports) of United States in 1984?
Offer a terse response. 1.95. What is the difference between the Imports(as % of merchandise exports) in Liberia in 1975 and the Imports(as % of merchandise exports) in Sierra Leone in 1984?
Offer a terse response. 0.02. What is the difference between the Imports(as % of merchandise exports) in Liberia in 1975 and the Imports(as % of merchandise exports) in United States in 1984?
Make the answer very short. -2.31. What is the difference between the Imports(as % of merchandise exports) of Sierra Leone in 1975 and the Imports(as % of merchandise exports) of United States in 1984?
Your response must be concise. -2.63. What is the difference between the Imports(as % of merchandise exports) in France in 1976 and the Imports(as % of merchandise exports) in Liberia in 1983?
Provide a short and direct response. 3.42. What is the difference between the Imports(as % of merchandise exports) of France in 1976 and the Imports(as % of merchandise exports) of Sierra Leone in 1983?
Provide a short and direct response. 4.57. What is the difference between the Imports(as % of merchandise exports) in France in 1976 and the Imports(as % of merchandise exports) in United States in 1983?
Offer a terse response. 1.32. What is the difference between the Imports(as % of merchandise exports) in Liberia in 1976 and the Imports(as % of merchandise exports) in Sierra Leone in 1983?
Provide a short and direct response. 0.3. What is the difference between the Imports(as % of merchandise exports) in Liberia in 1976 and the Imports(as % of merchandise exports) in United States in 1983?
Ensure brevity in your answer.  -2.94. What is the difference between the Imports(as % of merchandise exports) in Sierra Leone in 1976 and the Imports(as % of merchandise exports) in United States in 1983?
Provide a short and direct response. -3.08. What is the difference between the Imports(as % of merchandise exports) in France in 1976 and the Imports(as % of merchandise exports) in Liberia in 1984?
Your response must be concise. 3.84. What is the difference between the Imports(as % of merchandise exports) of France in 1976 and the Imports(as % of merchandise exports) of Sierra Leone in 1984?
Your answer should be very brief. 4.05. What is the difference between the Imports(as % of merchandise exports) in France in 1976 and the Imports(as % of merchandise exports) in United States in 1984?
Ensure brevity in your answer.  1.72. What is the difference between the Imports(as % of merchandise exports) of Liberia in 1976 and the Imports(as % of merchandise exports) of Sierra Leone in 1984?
Ensure brevity in your answer.  -0.22. What is the difference between the Imports(as % of merchandise exports) in Liberia in 1976 and the Imports(as % of merchandise exports) in United States in 1984?
Provide a succinct answer. -2.54. What is the difference between the Imports(as % of merchandise exports) in Sierra Leone in 1976 and the Imports(as % of merchandise exports) in United States in 1984?
Your answer should be very brief. -2.68. What is the difference between the Imports(as % of merchandise exports) of France in 1983 and the Imports(as % of merchandise exports) of Liberia in 1984?
Give a very brief answer. 2.6. What is the difference between the Imports(as % of merchandise exports) of France in 1983 and the Imports(as % of merchandise exports) of Sierra Leone in 1984?
Provide a succinct answer. 2.81. What is the difference between the Imports(as % of merchandise exports) in France in 1983 and the Imports(as % of merchandise exports) in United States in 1984?
Make the answer very short. 0.49. What is the difference between the Imports(as % of merchandise exports) of Liberia in 1983 and the Imports(as % of merchandise exports) of Sierra Leone in 1984?
Make the answer very short. 0.63. What is the difference between the Imports(as % of merchandise exports) in Liberia in 1983 and the Imports(as % of merchandise exports) in United States in 1984?
Offer a very short reply. -1.69. What is the difference between the Imports(as % of merchandise exports) of Sierra Leone in 1983 and the Imports(as % of merchandise exports) of United States in 1984?
Provide a succinct answer. -2.85. What is the average Imports(as % of merchandise exports) of France per year?
Make the answer very short. 5.54. What is the average Imports(as % of merchandise exports) in Liberia per year?
Provide a short and direct response. 1.11. What is the average Imports(as % of merchandise exports) of Sierra Leone per year?
Make the answer very short. 0.67. What is the average Imports(as % of merchandise exports) in United States per year?
Offer a terse response. 5.86. In the year 1963, what is the difference between the Imports(as % of merchandise exports) in France and Imports(as % of merchandise exports) in Liberia?
Offer a terse response. 5.22. In the year 1963, what is the difference between the Imports(as % of merchandise exports) of France and Imports(as % of merchandise exports) of Sierra Leone?
Provide a short and direct response. 5.7. In the year 1963, what is the difference between the Imports(as % of merchandise exports) in France and Imports(as % of merchandise exports) in United States?
Provide a short and direct response. -4.89. In the year 1963, what is the difference between the Imports(as % of merchandise exports) of Liberia and Imports(as % of merchandise exports) of Sierra Leone?
Give a very brief answer. 0.48. In the year 1963, what is the difference between the Imports(as % of merchandise exports) in Liberia and Imports(as % of merchandise exports) in United States?
Offer a terse response. -10.12. In the year 1963, what is the difference between the Imports(as % of merchandise exports) in Sierra Leone and Imports(as % of merchandise exports) in United States?
Offer a very short reply. -10.59. In the year 1972, what is the difference between the Imports(as % of merchandise exports) of France and Imports(as % of merchandise exports) of Liberia?
Offer a terse response. 5.09. In the year 1972, what is the difference between the Imports(as % of merchandise exports) of France and Imports(as % of merchandise exports) of Sierra Leone?
Ensure brevity in your answer.  5.63. In the year 1972, what is the difference between the Imports(as % of merchandise exports) of France and Imports(as % of merchandise exports) of United States?
Give a very brief answer. 0.17. In the year 1972, what is the difference between the Imports(as % of merchandise exports) in Liberia and Imports(as % of merchandise exports) in Sierra Leone?
Ensure brevity in your answer.  0.54. In the year 1972, what is the difference between the Imports(as % of merchandise exports) of Liberia and Imports(as % of merchandise exports) of United States?
Make the answer very short. -4.92. In the year 1972, what is the difference between the Imports(as % of merchandise exports) in Sierra Leone and Imports(as % of merchandise exports) in United States?
Ensure brevity in your answer.  -5.46. In the year 1973, what is the difference between the Imports(as % of merchandise exports) in France and Imports(as % of merchandise exports) in Liberia?
Your response must be concise. 5.55. In the year 1973, what is the difference between the Imports(as % of merchandise exports) in France and Imports(as % of merchandise exports) in Sierra Leone?
Offer a terse response. 5.88. In the year 1973, what is the difference between the Imports(as % of merchandise exports) of France and Imports(as % of merchandise exports) of United States?
Provide a succinct answer. 0.38. In the year 1973, what is the difference between the Imports(as % of merchandise exports) of Liberia and Imports(as % of merchandise exports) of Sierra Leone?
Ensure brevity in your answer.  0.33. In the year 1973, what is the difference between the Imports(as % of merchandise exports) in Liberia and Imports(as % of merchandise exports) in United States?
Your response must be concise. -5.17. In the year 1973, what is the difference between the Imports(as % of merchandise exports) of Sierra Leone and Imports(as % of merchandise exports) of United States?
Your answer should be very brief. -5.5. In the year 1974, what is the difference between the Imports(as % of merchandise exports) in France and Imports(as % of merchandise exports) in Liberia?
Offer a very short reply. 6.04. In the year 1974, what is the difference between the Imports(as % of merchandise exports) in France and Imports(as % of merchandise exports) in Sierra Leone?
Your answer should be compact. 6.41. In the year 1974, what is the difference between the Imports(as % of merchandise exports) of France and Imports(as % of merchandise exports) of United States?
Your answer should be very brief. 0.69. In the year 1974, what is the difference between the Imports(as % of merchandise exports) of Liberia and Imports(as % of merchandise exports) of Sierra Leone?
Give a very brief answer. 0.37. In the year 1974, what is the difference between the Imports(as % of merchandise exports) in Liberia and Imports(as % of merchandise exports) in United States?
Provide a short and direct response. -5.35. In the year 1974, what is the difference between the Imports(as % of merchandise exports) of Sierra Leone and Imports(as % of merchandise exports) of United States?
Ensure brevity in your answer.  -5.72. In the year 1975, what is the difference between the Imports(as % of merchandise exports) of France and Imports(as % of merchandise exports) of Liberia?
Your answer should be very brief. 4.26. In the year 1975, what is the difference between the Imports(as % of merchandise exports) in France and Imports(as % of merchandise exports) in Sierra Leone?
Your answer should be very brief. 4.58. In the year 1975, what is the difference between the Imports(as % of merchandise exports) of France and Imports(as % of merchandise exports) of United States?
Your response must be concise. 0.25. In the year 1975, what is the difference between the Imports(as % of merchandise exports) in Liberia and Imports(as % of merchandise exports) in Sierra Leone?
Provide a short and direct response. 0.33. In the year 1975, what is the difference between the Imports(as % of merchandise exports) of Liberia and Imports(as % of merchandise exports) of United States?
Offer a very short reply. -4.01. In the year 1975, what is the difference between the Imports(as % of merchandise exports) of Sierra Leone and Imports(as % of merchandise exports) of United States?
Make the answer very short. -4.34. In the year 1976, what is the difference between the Imports(as % of merchandise exports) of France and Imports(as % of merchandise exports) of Liberia?
Offer a very short reply. 4.27. In the year 1976, what is the difference between the Imports(as % of merchandise exports) in France and Imports(as % of merchandise exports) in Sierra Leone?
Give a very brief answer. 4.4. In the year 1976, what is the difference between the Imports(as % of merchandise exports) of France and Imports(as % of merchandise exports) of United States?
Make the answer very short. 0.07. In the year 1976, what is the difference between the Imports(as % of merchandise exports) of Liberia and Imports(as % of merchandise exports) of Sierra Leone?
Provide a short and direct response. 0.14. In the year 1976, what is the difference between the Imports(as % of merchandise exports) in Liberia and Imports(as % of merchandise exports) in United States?
Your response must be concise. -4.2. In the year 1976, what is the difference between the Imports(as % of merchandise exports) in Sierra Leone and Imports(as % of merchandise exports) in United States?
Offer a terse response. -4.34. In the year 1983, what is the difference between the Imports(as % of merchandise exports) in France and Imports(as % of merchandise exports) in Liberia?
Your response must be concise. 2.18. In the year 1983, what is the difference between the Imports(as % of merchandise exports) in France and Imports(as % of merchandise exports) in Sierra Leone?
Offer a very short reply. 3.33. In the year 1983, what is the difference between the Imports(as % of merchandise exports) in France and Imports(as % of merchandise exports) in United States?
Ensure brevity in your answer.  0.08. In the year 1983, what is the difference between the Imports(as % of merchandise exports) in Liberia and Imports(as % of merchandise exports) in Sierra Leone?
Give a very brief answer. 1.15. In the year 1983, what is the difference between the Imports(as % of merchandise exports) in Liberia and Imports(as % of merchandise exports) in United States?
Provide a succinct answer. -2.1. In the year 1983, what is the difference between the Imports(as % of merchandise exports) in Sierra Leone and Imports(as % of merchandise exports) in United States?
Provide a succinct answer. -3.25. In the year 1984, what is the difference between the Imports(as % of merchandise exports) in France and Imports(as % of merchandise exports) in Liberia?
Your answer should be very brief. 2.8. In the year 1984, what is the difference between the Imports(as % of merchandise exports) in France and Imports(as % of merchandise exports) in Sierra Leone?
Offer a terse response. 3.01. In the year 1984, what is the difference between the Imports(as % of merchandise exports) in France and Imports(as % of merchandise exports) in United States?
Ensure brevity in your answer.  0.68. In the year 1984, what is the difference between the Imports(as % of merchandise exports) of Liberia and Imports(as % of merchandise exports) of Sierra Leone?
Provide a succinct answer. 0.21. In the year 1984, what is the difference between the Imports(as % of merchandise exports) of Liberia and Imports(as % of merchandise exports) of United States?
Your response must be concise. -2.12. In the year 1984, what is the difference between the Imports(as % of merchandise exports) in Sierra Leone and Imports(as % of merchandise exports) in United States?
Provide a short and direct response. -2.32. What is the ratio of the Imports(as % of merchandise exports) of France in 1963 to that in 1972?
Ensure brevity in your answer.  1.09. What is the ratio of the Imports(as % of merchandise exports) of Liberia in 1963 to that in 1972?
Your answer should be very brief. 1.42. What is the ratio of the Imports(as % of merchandise exports) of Sierra Leone in 1963 to that in 1972?
Ensure brevity in your answer.  2.18. What is the ratio of the Imports(as % of merchandise exports) of United States in 1963 to that in 1972?
Keep it short and to the point. 1.96. What is the ratio of the Imports(as % of merchandise exports) in France in 1963 to that in 1973?
Make the answer very short. 1.04. What is the ratio of the Imports(as % of merchandise exports) of Liberia in 1963 to that in 1973?
Your answer should be compact. 1.73. What is the ratio of the Imports(as % of merchandise exports) in Sierra Leone in 1963 to that in 1973?
Give a very brief answer. 1.96. What is the ratio of the Imports(as % of merchandise exports) of United States in 1963 to that in 1973?
Your answer should be compact. 1.93. What is the ratio of the Imports(as % of merchandise exports) of France in 1963 to that in 1974?
Your response must be concise. 0.96. What is the ratio of the Imports(as % of merchandise exports) in Liberia in 1963 to that in 1974?
Your answer should be very brief. 1.65. What is the ratio of the Imports(as % of merchandise exports) of Sierra Leone in 1963 to that in 1974?
Provide a short and direct response. 1.97. What is the ratio of the Imports(as % of merchandise exports) of United States in 1963 to that in 1974?
Offer a very short reply. 1.86. What is the ratio of the Imports(as % of merchandise exports) of France in 1963 to that in 1975?
Your answer should be very brief. 1.21. What is the ratio of the Imports(as % of merchandise exports) of Liberia in 1963 to that in 1975?
Offer a very short reply. 1.16. What is the ratio of the Imports(as % of merchandise exports) in Sierra Leone in 1963 to that in 1975?
Give a very brief answer. 1.04. What is the ratio of the Imports(as % of merchandise exports) of United States in 1963 to that in 1975?
Offer a terse response. 2.22. What is the ratio of the Imports(as % of merchandise exports) of France in 1963 to that in 1976?
Give a very brief answer. 1.27. What is the ratio of the Imports(as % of merchandise exports) in Liberia in 1963 to that in 1976?
Keep it short and to the point. 1.47. What is the ratio of the Imports(as % of merchandise exports) of Sierra Leone in 1963 to that in 1976?
Ensure brevity in your answer.  1.11. What is the ratio of the Imports(as % of merchandise exports) of United States in 1963 to that in 1976?
Make the answer very short. 2.24. What is the ratio of the Imports(as % of merchandise exports) of France in 1963 to that in 1983?
Give a very brief answer. 1.67. What is the ratio of the Imports(as % of merchandise exports) of Liberia in 1963 to that in 1983?
Make the answer very short. 0.76. What is the ratio of the Imports(as % of merchandise exports) of Sierra Leone in 1963 to that in 1983?
Give a very brief answer. 1.42. What is the ratio of the Imports(as % of merchandise exports) of United States in 1963 to that in 1983?
Offer a very short reply. 2.98. What is the ratio of the Imports(as % of merchandise exports) of France in 1963 to that in 1984?
Provide a succinct answer. 1.59. What is the ratio of the Imports(as % of merchandise exports) of Liberia in 1963 to that in 1984?
Offer a very short reply. 1. What is the ratio of the Imports(as % of merchandise exports) of Sierra Leone in 1963 to that in 1984?
Provide a short and direct response. 0.75. What is the ratio of the Imports(as % of merchandise exports) in United States in 1963 to that in 1984?
Your answer should be very brief. 3.32. What is the ratio of the Imports(as % of merchandise exports) in France in 1972 to that in 1973?
Ensure brevity in your answer.  0.95. What is the ratio of the Imports(as % of merchandise exports) of Liberia in 1972 to that in 1973?
Offer a very short reply. 1.22. What is the ratio of the Imports(as % of merchandise exports) in Sierra Leone in 1972 to that in 1973?
Offer a very short reply. 0.9. What is the ratio of the Imports(as % of merchandise exports) of United States in 1972 to that in 1973?
Your answer should be compact. 0.99. What is the ratio of the Imports(as % of merchandise exports) of France in 1972 to that in 1974?
Offer a terse response. 0.88. What is the ratio of the Imports(as % of merchandise exports) in Liberia in 1972 to that in 1974?
Offer a terse response. 1.16. What is the ratio of the Imports(as % of merchandise exports) of Sierra Leone in 1972 to that in 1974?
Offer a terse response. 0.9. What is the ratio of the Imports(as % of merchandise exports) in United States in 1972 to that in 1974?
Ensure brevity in your answer.  0.95. What is the ratio of the Imports(as % of merchandise exports) of France in 1972 to that in 1975?
Your answer should be compact. 1.12. What is the ratio of the Imports(as % of merchandise exports) in Liberia in 1972 to that in 1975?
Provide a succinct answer. 0.82. What is the ratio of the Imports(as % of merchandise exports) of Sierra Leone in 1972 to that in 1975?
Give a very brief answer. 0.48. What is the ratio of the Imports(as % of merchandise exports) of United States in 1972 to that in 1975?
Keep it short and to the point. 1.14. What is the ratio of the Imports(as % of merchandise exports) in France in 1972 to that in 1976?
Your answer should be compact. 1.17. What is the ratio of the Imports(as % of merchandise exports) in Liberia in 1972 to that in 1976?
Make the answer very short. 1.04. What is the ratio of the Imports(as % of merchandise exports) in Sierra Leone in 1972 to that in 1976?
Provide a short and direct response. 0.51. What is the ratio of the Imports(as % of merchandise exports) in United States in 1972 to that in 1976?
Provide a short and direct response. 1.15. What is the ratio of the Imports(as % of merchandise exports) in France in 1972 to that in 1983?
Offer a terse response. 1.53. What is the ratio of the Imports(as % of merchandise exports) in Liberia in 1972 to that in 1983?
Provide a short and direct response. 0.53. What is the ratio of the Imports(as % of merchandise exports) in Sierra Leone in 1972 to that in 1983?
Give a very brief answer. 0.65. What is the ratio of the Imports(as % of merchandise exports) of United States in 1972 to that in 1983?
Offer a terse response. 1.52. What is the ratio of the Imports(as % of merchandise exports) of France in 1972 to that in 1984?
Provide a short and direct response. 1.46. What is the ratio of the Imports(as % of merchandise exports) of Liberia in 1972 to that in 1984?
Provide a succinct answer. 0.7. What is the ratio of the Imports(as % of merchandise exports) in Sierra Leone in 1972 to that in 1984?
Keep it short and to the point. 0.35. What is the ratio of the Imports(as % of merchandise exports) of United States in 1972 to that in 1984?
Your answer should be compact. 1.7. What is the ratio of the Imports(as % of merchandise exports) in France in 1973 to that in 1974?
Your answer should be compact. 0.92. What is the ratio of the Imports(as % of merchandise exports) of Liberia in 1973 to that in 1974?
Make the answer very short. 0.95. What is the ratio of the Imports(as % of merchandise exports) of United States in 1973 to that in 1974?
Provide a succinct answer. 0.96. What is the ratio of the Imports(as % of merchandise exports) of France in 1973 to that in 1975?
Offer a terse response. 1.17. What is the ratio of the Imports(as % of merchandise exports) in Liberia in 1973 to that in 1975?
Your answer should be compact. 0.67. What is the ratio of the Imports(as % of merchandise exports) in Sierra Leone in 1973 to that in 1975?
Your response must be concise. 0.53. What is the ratio of the Imports(as % of merchandise exports) of United States in 1973 to that in 1975?
Ensure brevity in your answer.  1.15. What is the ratio of the Imports(as % of merchandise exports) in France in 1973 to that in 1976?
Provide a short and direct response. 1.22. What is the ratio of the Imports(as % of merchandise exports) of Liberia in 1973 to that in 1976?
Give a very brief answer. 0.85. What is the ratio of the Imports(as % of merchandise exports) of Sierra Leone in 1973 to that in 1976?
Give a very brief answer. 0.56. What is the ratio of the Imports(as % of merchandise exports) in United States in 1973 to that in 1976?
Offer a terse response. 1.16. What is the ratio of the Imports(as % of merchandise exports) in France in 1973 to that in 1983?
Make the answer very short. 1.61. What is the ratio of the Imports(as % of merchandise exports) of Liberia in 1973 to that in 1983?
Your answer should be compact. 0.44. What is the ratio of the Imports(as % of merchandise exports) in Sierra Leone in 1973 to that in 1983?
Give a very brief answer. 0.72. What is the ratio of the Imports(as % of merchandise exports) of United States in 1973 to that in 1983?
Your answer should be very brief. 1.54. What is the ratio of the Imports(as % of merchandise exports) in France in 1973 to that in 1984?
Offer a very short reply. 1.53. What is the ratio of the Imports(as % of merchandise exports) of Liberia in 1973 to that in 1984?
Your answer should be compact. 0.58. What is the ratio of the Imports(as % of merchandise exports) in Sierra Leone in 1973 to that in 1984?
Offer a very short reply. 0.38. What is the ratio of the Imports(as % of merchandise exports) in United States in 1973 to that in 1984?
Your answer should be compact. 1.72. What is the ratio of the Imports(as % of merchandise exports) in France in 1974 to that in 1975?
Keep it short and to the point. 1.27. What is the ratio of the Imports(as % of merchandise exports) of Liberia in 1974 to that in 1975?
Ensure brevity in your answer.  0.7. What is the ratio of the Imports(as % of merchandise exports) in Sierra Leone in 1974 to that in 1975?
Keep it short and to the point. 0.53. What is the ratio of the Imports(as % of merchandise exports) in United States in 1974 to that in 1975?
Offer a very short reply. 1.19. What is the ratio of the Imports(as % of merchandise exports) of France in 1974 to that in 1976?
Your answer should be compact. 1.32. What is the ratio of the Imports(as % of merchandise exports) of Liberia in 1974 to that in 1976?
Make the answer very short. 0.89. What is the ratio of the Imports(as % of merchandise exports) of Sierra Leone in 1974 to that in 1976?
Give a very brief answer. 0.56. What is the ratio of the Imports(as % of merchandise exports) of United States in 1974 to that in 1976?
Provide a succinct answer. 1.21. What is the ratio of the Imports(as % of merchandise exports) in France in 1974 to that in 1983?
Provide a short and direct response. 1.74. What is the ratio of the Imports(as % of merchandise exports) in Liberia in 1974 to that in 1983?
Provide a succinct answer. 0.46. What is the ratio of the Imports(as % of merchandise exports) in Sierra Leone in 1974 to that in 1983?
Give a very brief answer. 0.72. What is the ratio of the Imports(as % of merchandise exports) of United States in 1974 to that in 1983?
Ensure brevity in your answer.  1.6. What is the ratio of the Imports(as % of merchandise exports) in France in 1974 to that in 1984?
Keep it short and to the point. 1.66. What is the ratio of the Imports(as % of merchandise exports) of Liberia in 1974 to that in 1984?
Make the answer very short. 0.6. What is the ratio of the Imports(as % of merchandise exports) of Sierra Leone in 1974 to that in 1984?
Provide a succinct answer. 0.38. What is the ratio of the Imports(as % of merchandise exports) of United States in 1974 to that in 1984?
Provide a succinct answer. 1.79. What is the ratio of the Imports(as % of merchandise exports) in France in 1975 to that in 1976?
Make the answer very short. 1.04. What is the ratio of the Imports(as % of merchandise exports) in Liberia in 1975 to that in 1976?
Offer a very short reply. 1.26. What is the ratio of the Imports(as % of merchandise exports) of Sierra Leone in 1975 to that in 1976?
Your answer should be compact. 1.06. What is the ratio of the Imports(as % of merchandise exports) in United States in 1975 to that in 1976?
Your answer should be very brief. 1.01. What is the ratio of the Imports(as % of merchandise exports) in France in 1975 to that in 1983?
Ensure brevity in your answer.  1.37. What is the ratio of the Imports(as % of merchandise exports) in Liberia in 1975 to that in 1983?
Offer a very short reply. 0.65. What is the ratio of the Imports(as % of merchandise exports) in Sierra Leone in 1975 to that in 1983?
Keep it short and to the point. 1.36. What is the ratio of the Imports(as % of merchandise exports) in United States in 1975 to that in 1983?
Your response must be concise. 1.34. What is the ratio of the Imports(as % of merchandise exports) in France in 1975 to that in 1984?
Provide a succinct answer. 1.31. What is the ratio of the Imports(as % of merchandise exports) of Liberia in 1975 to that in 1984?
Ensure brevity in your answer.  0.86. What is the ratio of the Imports(as % of merchandise exports) in Sierra Leone in 1975 to that in 1984?
Give a very brief answer. 0.72. What is the ratio of the Imports(as % of merchandise exports) in United States in 1975 to that in 1984?
Your response must be concise. 1.5. What is the ratio of the Imports(as % of merchandise exports) of France in 1976 to that in 1983?
Make the answer very short. 1.32. What is the ratio of the Imports(as % of merchandise exports) in Liberia in 1976 to that in 1983?
Provide a succinct answer. 0.51. What is the ratio of the Imports(as % of merchandise exports) in Sierra Leone in 1976 to that in 1983?
Make the answer very short. 1.28. What is the ratio of the Imports(as % of merchandise exports) in United States in 1976 to that in 1983?
Give a very brief answer. 1.33. What is the ratio of the Imports(as % of merchandise exports) of France in 1976 to that in 1984?
Ensure brevity in your answer.  1.25. What is the ratio of the Imports(as % of merchandise exports) of Liberia in 1976 to that in 1984?
Ensure brevity in your answer.  0.68. What is the ratio of the Imports(as % of merchandise exports) in Sierra Leone in 1976 to that in 1984?
Ensure brevity in your answer.  0.68. What is the ratio of the Imports(as % of merchandise exports) in United States in 1976 to that in 1984?
Give a very brief answer. 1.48. What is the ratio of the Imports(as % of merchandise exports) in France in 1983 to that in 1984?
Your answer should be very brief. 0.95. What is the ratio of the Imports(as % of merchandise exports) of Liberia in 1983 to that in 1984?
Offer a very short reply. 1.32. What is the ratio of the Imports(as % of merchandise exports) of Sierra Leone in 1983 to that in 1984?
Offer a very short reply. 0.53. What is the ratio of the Imports(as % of merchandise exports) of United States in 1983 to that in 1984?
Keep it short and to the point. 1.12. What is the difference between the highest and the second highest Imports(as % of merchandise exports) in France?
Make the answer very short. 0.29. What is the difference between the highest and the second highest Imports(as % of merchandise exports) in Liberia?
Your response must be concise. 0.42. What is the difference between the highest and the second highest Imports(as % of merchandise exports) in Sierra Leone?
Provide a succinct answer. 0.27. What is the difference between the highest and the second highest Imports(as % of merchandise exports) of United States?
Provide a succinct answer. 5.29. What is the difference between the highest and the lowest Imports(as % of merchandise exports) in France?
Offer a very short reply. 2.91. What is the difference between the highest and the lowest Imports(as % of merchandise exports) in Liberia?
Make the answer very short. 0.98. What is the difference between the highest and the lowest Imports(as % of merchandise exports) of Sierra Leone?
Make the answer very short. 0.73. What is the difference between the highest and the lowest Imports(as % of merchandise exports) in United States?
Ensure brevity in your answer.  8. 